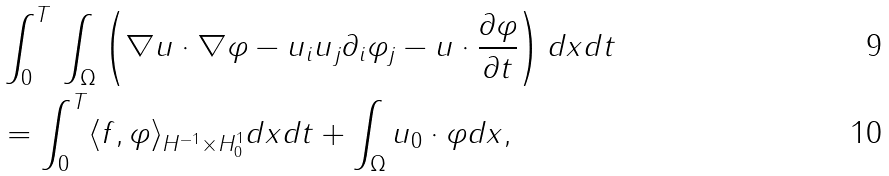Convert formula to latex. <formula><loc_0><loc_0><loc_500><loc_500>& \int _ { 0 } ^ { T } \, \int _ { \Omega } \left ( \nabla u \cdot \nabla \varphi - u _ { i } u _ { j } \partial _ { i } \varphi _ { j } - u \cdot \frac { \partial \varphi } { \partial t } \right ) d x d t \\ & = \int _ { 0 } ^ { T } \langle f , \varphi \rangle _ { H ^ { - 1 } \times H ^ { 1 } _ { 0 } } d x d t + \int _ { \Omega } u _ { 0 } \cdot \varphi d x ,</formula> 